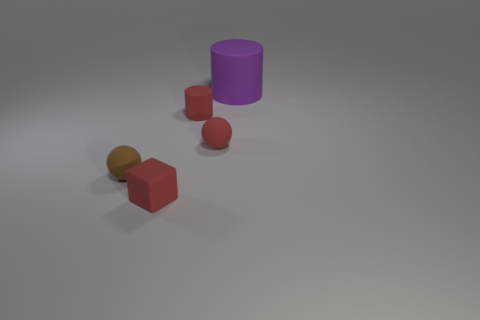Are there any other things that have the same size as the purple rubber cylinder?
Offer a very short reply. No. What is the size of the thing that is to the right of the small red rubber ball?
Provide a succinct answer. Large. What number of things are either rubber cylinders that are in front of the big purple thing or cylinders to the left of the big purple object?
Offer a very short reply. 1. How many other objects are there of the same color as the big matte cylinder?
Provide a short and direct response. 0. Does the small brown matte thing have the same shape as the tiny red rubber object that is to the right of the tiny red matte cylinder?
Offer a terse response. Yes. Is the number of small red balls left of the small red cylinder less than the number of small rubber things left of the red cube?
Ensure brevity in your answer.  Yes. Do the rubber block and the tiny rubber cylinder have the same color?
Offer a very short reply. Yes. There is a small brown object that is made of the same material as the red cylinder; what is its shape?
Provide a succinct answer. Sphere. What number of other tiny rubber objects are the same shape as the brown thing?
Make the answer very short. 1. The tiny red thing that is in front of the small red matte thing to the right of the small cylinder is what shape?
Give a very brief answer. Cube. 